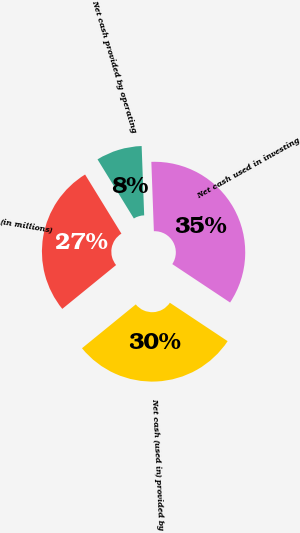Convert chart. <chart><loc_0><loc_0><loc_500><loc_500><pie_chart><fcel>(in millions)<fcel>Net cash provided by operating<fcel>Net cash used in investing<fcel>Net cash (used in) provided by<nl><fcel>27.11%<fcel>8.19%<fcel>34.92%<fcel>29.78%<nl></chart> 